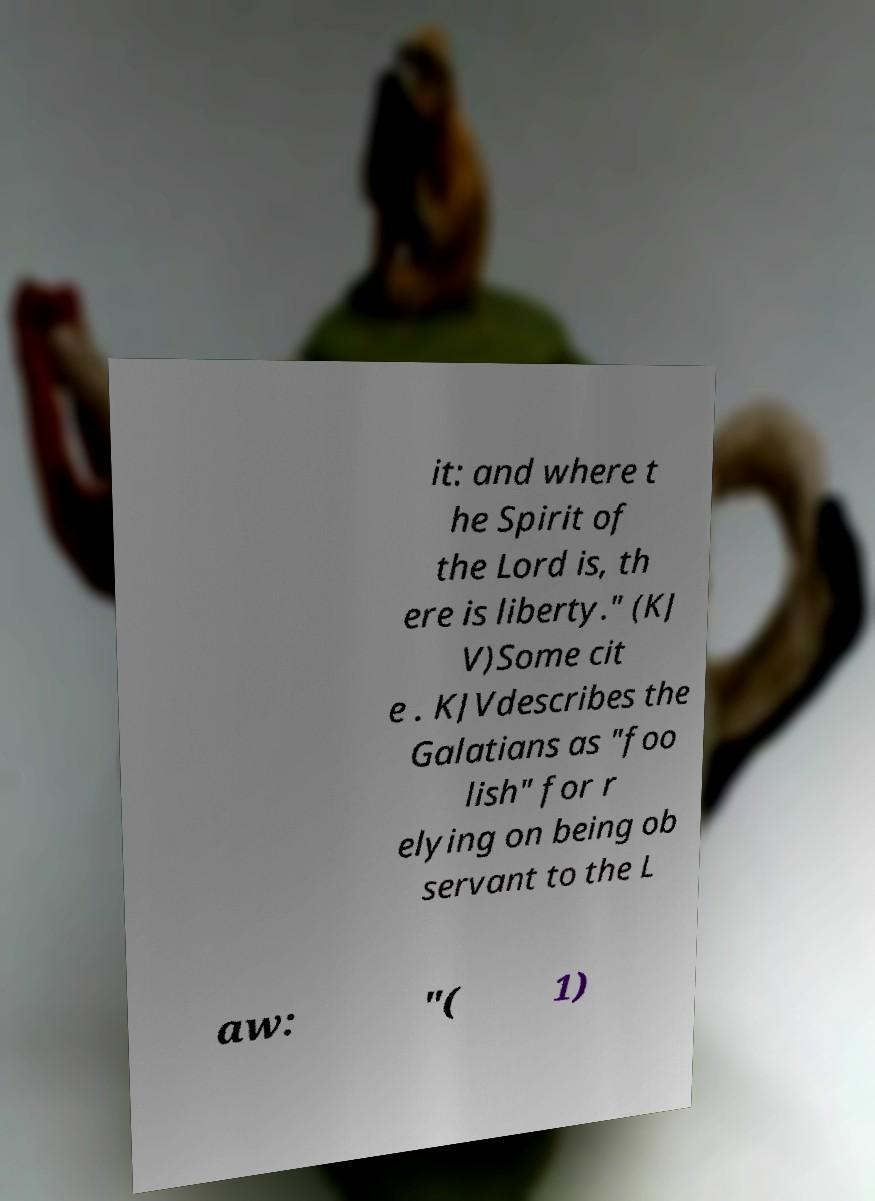Could you assist in decoding the text presented in this image and type it out clearly? it: and where t he Spirit of the Lord is, th ere is liberty." (KJ V)Some cit e . KJVdescribes the Galatians as "foo lish" for r elying on being ob servant to the L aw: "( 1) 